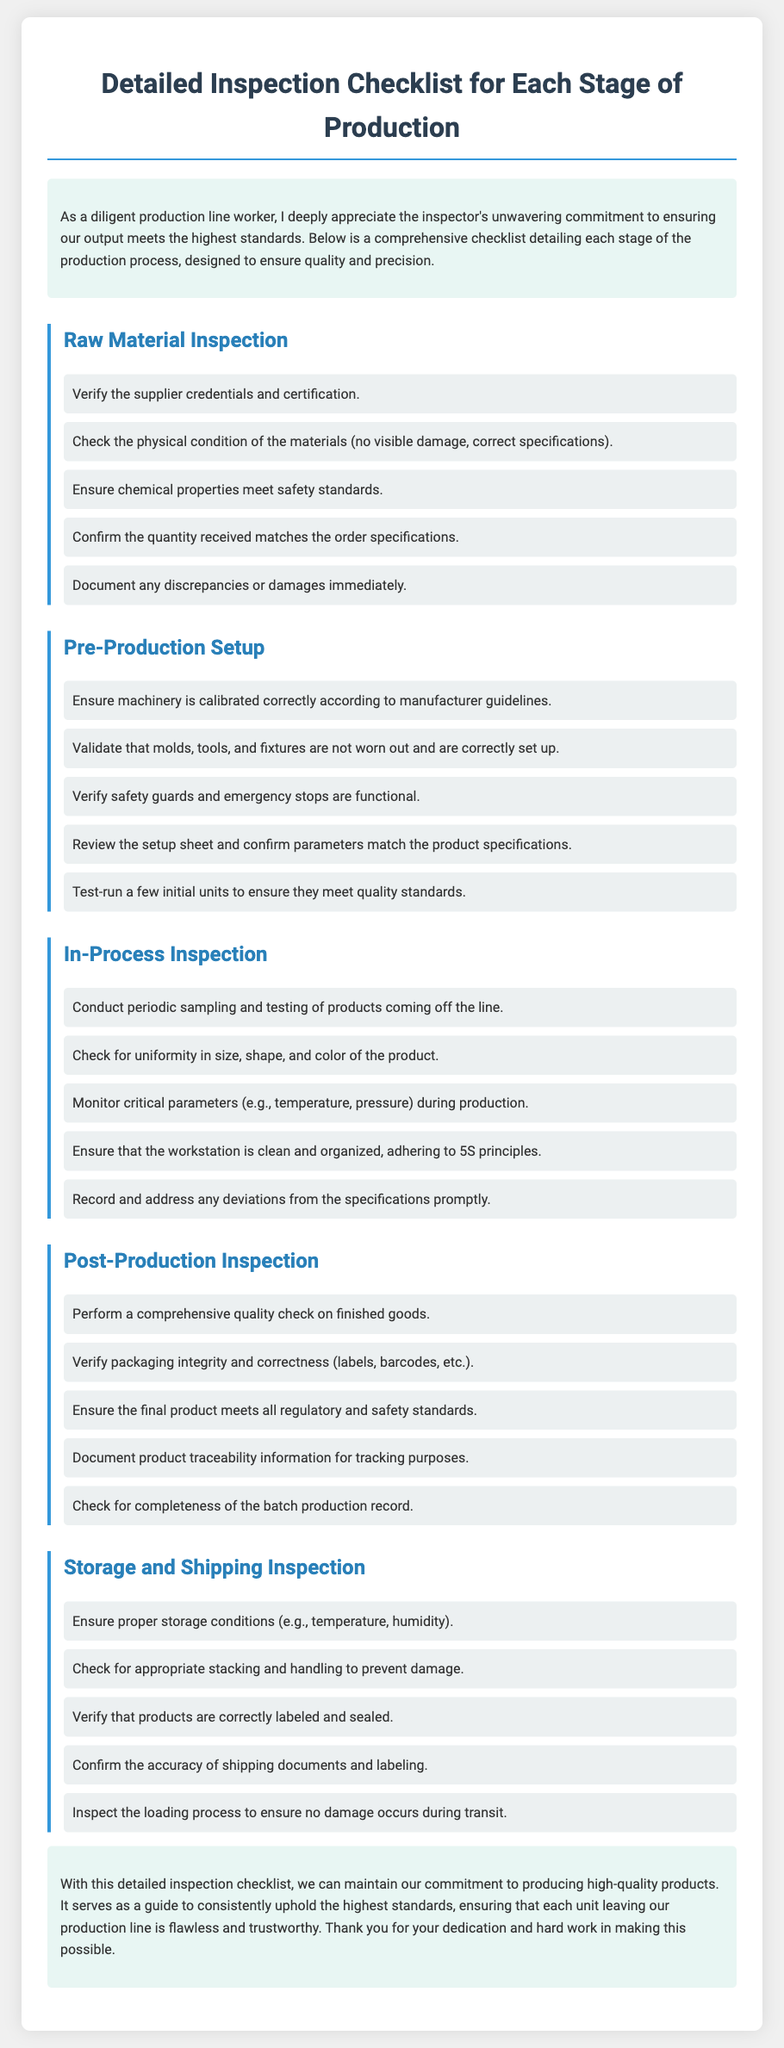what is the title of the document? The title of the document is displayed prominently at the top of the page, indicating its purpose.
Answer: Detailed Inspection Checklist for Each Stage of Production how many stages of production are listed in the document? The document outlines five distinct stages of production, each with specific inspection points.
Answer: 5 what is the first item in the Raw Material Inspection checklist? The first item in this inspection checklist highlights the importance of supplier credentials and their authenticity.
Answer: Verify the supplier credentials and certification which stage involves checking the accuracy of shipping documents? This stage focuses on the final steps before products leave the facility, ensuring all details are correct.
Answer: Storage and Shipping Inspection what principle is mentioned for maintaining cleanliness at the workstation during In-Process Inspection? This principle is aimed at promoting an organized and efficient working environment.
Answer: 5S principles what type of check is performed on finished goods in the Post-Production Inspection? This type of check consists of a thorough evaluation to ensure quality before products are released.
Answer: Comprehensive quality check which item checks for proper storage conditions? This item ensures that the environment where products are held is suitable and meets certain requirements.
Answer: Ensure proper storage conditions what should be done if discrepancies or damages are found during inspection? Documenting discrepancies is crucial for maintaining records and addressing issues promptly.
Answer: Document any discrepancies or damages immediately 